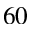<formula> <loc_0><loc_0><loc_500><loc_500>^ { 6 0 }</formula> 